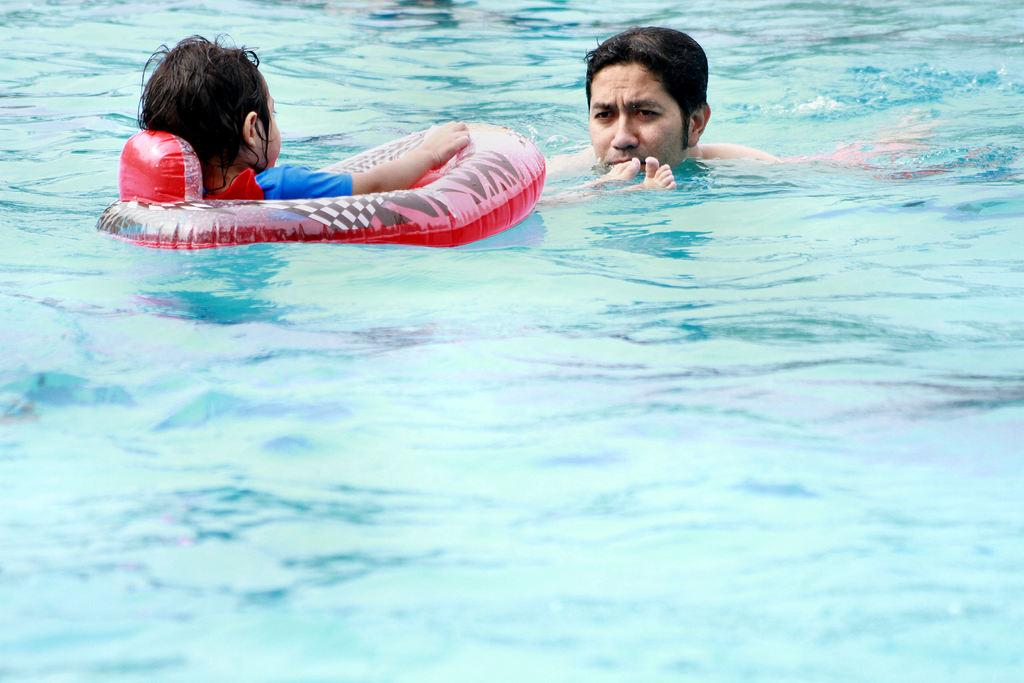What is the main subject of the image? There is a child in the image. What is the child doing in the image? The child is sitting in a tube and swimming in the water. What type of stove is visible in the image? There is no stove present in the image; it features a child swimming in the water. How many people are in the group shown in the image? There is no group of people present in the image; it features a single child swimming. 